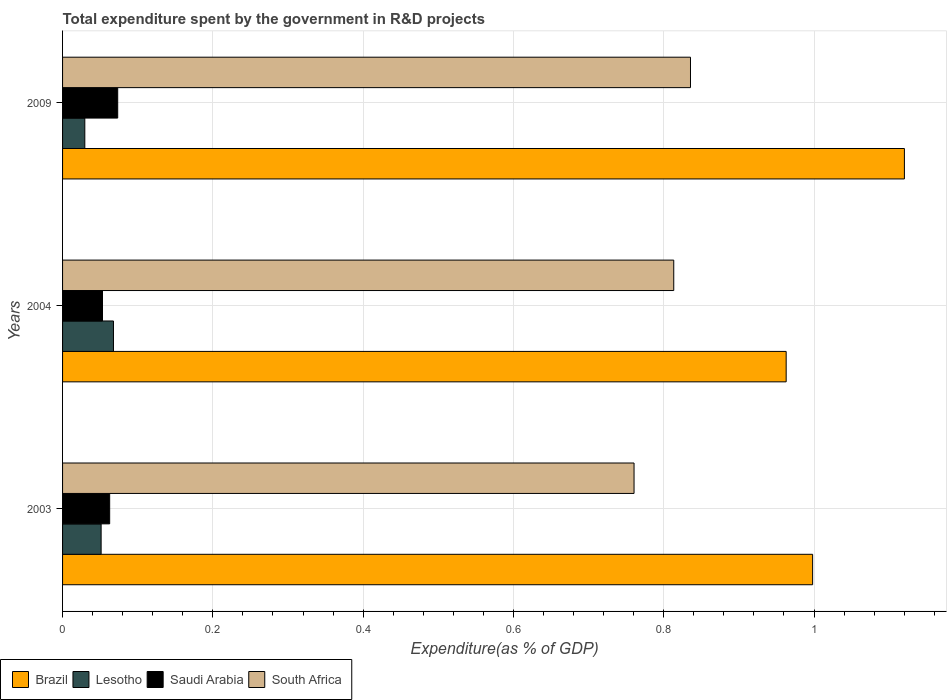Are the number of bars per tick equal to the number of legend labels?
Give a very brief answer. Yes. Are the number of bars on each tick of the Y-axis equal?
Provide a succinct answer. Yes. How many bars are there on the 3rd tick from the top?
Ensure brevity in your answer.  4. How many bars are there on the 1st tick from the bottom?
Make the answer very short. 4. In how many cases, is the number of bars for a given year not equal to the number of legend labels?
Your response must be concise. 0. What is the total expenditure spent by the government in R&D projects in Lesotho in 2003?
Your answer should be very brief. 0.05. Across all years, what is the maximum total expenditure spent by the government in R&D projects in South Africa?
Your response must be concise. 0.84. Across all years, what is the minimum total expenditure spent by the government in R&D projects in Lesotho?
Offer a terse response. 0.03. In which year was the total expenditure spent by the government in R&D projects in Brazil maximum?
Offer a terse response. 2009. What is the total total expenditure spent by the government in R&D projects in Saudi Arabia in the graph?
Keep it short and to the point. 0.19. What is the difference between the total expenditure spent by the government in R&D projects in South Africa in 2003 and that in 2004?
Ensure brevity in your answer.  -0.05. What is the difference between the total expenditure spent by the government in R&D projects in Saudi Arabia in 2009 and the total expenditure spent by the government in R&D projects in Lesotho in 2003?
Your response must be concise. 0.02. What is the average total expenditure spent by the government in R&D projects in South Africa per year?
Ensure brevity in your answer.  0.8. In the year 2009, what is the difference between the total expenditure spent by the government in R&D projects in Saudi Arabia and total expenditure spent by the government in R&D projects in South Africa?
Offer a terse response. -0.76. What is the ratio of the total expenditure spent by the government in R&D projects in Lesotho in 2004 to that in 2009?
Ensure brevity in your answer.  2.29. Is the total expenditure spent by the government in R&D projects in Lesotho in 2004 less than that in 2009?
Offer a terse response. No. Is the difference between the total expenditure spent by the government in R&D projects in Saudi Arabia in 2004 and 2009 greater than the difference between the total expenditure spent by the government in R&D projects in South Africa in 2004 and 2009?
Keep it short and to the point. Yes. What is the difference between the highest and the second highest total expenditure spent by the government in R&D projects in South Africa?
Make the answer very short. 0.02. What is the difference between the highest and the lowest total expenditure spent by the government in R&D projects in South Africa?
Make the answer very short. 0.08. Is the sum of the total expenditure spent by the government in R&D projects in Brazil in 2004 and 2009 greater than the maximum total expenditure spent by the government in R&D projects in Lesotho across all years?
Ensure brevity in your answer.  Yes. What does the 1st bar from the top in 2004 represents?
Give a very brief answer. South Africa. What does the 2nd bar from the bottom in 2003 represents?
Provide a succinct answer. Lesotho. How many bars are there?
Offer a very short reply. 12. Are all the bars in the graph horizontal?
Your answer should be very brief. Yes. Does the graph contain any zero values?
Your answer should be very brief. No. Does the graph contain grids?
Offer a very short reply. Yes. How many legend labels are there?
Offer a very short reply. 4. What is the title of the graph?
Keep it short and to the point. Total expenditure spent by the government in R&D projects. What is the label or title of the X-axis?
Give a very brief answer. Expenditure(as % of GDP). What is the Expenditure(as % of GDP) in Brazil in 2003?
Keep it short and to the point. 1. What is the Expenditure(as % of GDP) of Lesotho in 2003?
Make the answer very short. 0.05. What is the Expenditure(as % of GDP) of Saudi Arabia in 2003?
Your answer should be very brief. 0.06. What is the Expenditure(as % of GDP) in South Africa in 2003?
Ensure brevity in your answer.  0.76. What is the Expenditure(as % of GDP) in Brazil in 2004?
Your response must be concise. 0.96. What is the Expenditure(as % of GDP) in Lesotho in 2004?
Provide a short and direct response. 0.07. What is the Expenditure(as % of GDP) of Saudi Arabia in 2004?
Ensure brevity in your answer.  0.05. What is the Expenditure(as % of GDP) of South Africa in 2004?
Provide a short and direct response. 0.81. What is the Expenditure(as % of GDP) in Brazil in 2009?
Provide a short and direct response. 1.12. What is the Expenditure(as % of GDP) in Lesotho in 2009?
Your response must be concise. 0.03. What is the Expenditure(as % of GDP) in Saudi Arabia in 2009?
Offer a very short reply. 0.07. What is the Expenditure(as % of GDP) of South Africa in 2009?
Provide a short and direct response. 0.84. Across all years, what is the maximum Expenditure(as % of GDP) of Brazil?
Make the answer very short. 1.12. Across all years, what is the maximum Expenditure(as % of GDP) in Lesotho?
Your answer should be compact. 0.07. Across all years, what is the maximum Expenditure(as % of GDP) in Saudi Arabia?
Provide a short and direct response. 0.07. Across all years, what is the maximum Expenditure(as % of GDP) of South Africa?
Provide a succinct answer. 0.84. Across all years, what is the minimum Expenditure(as % of GDP) in Brazil?
Make the answer very short. 0.96. Across all years, what is the minimum Expenditure(as % of GDP) in Lesotho?
Make the answer very short. 0.03. Across all years, what is the minimum Expenditure(as % of GDP) in Saudi Arabia?
Offer a terse response. 0.05. Across all years, what is the minimum Expenditure(as % of GDP) of South Africa?
Give a very brief answer. 0.76. What is the total Expenditure(as % of GDP) in Brazil in the graph?
Keep it short and to the point. 3.08. What is the total Expenditure(as % of GDP) of Lesotho in the graph?
Provide a short and direct response. 0.15. What is the total Expenditure(as % of GDP) of Saudi Arabia in the graph?
Your response must be concise. 0.19. What is the total Expenditure(as % of GDP) of South Africa in the graph?
Your answer should be compact. 2.41. What is the difference between the Expenditure(as % of GDP) in Brazil in 2003 and that in 2004?
Make the answer very short. 0.04. What is the difference between the Expenditure(as % of GDP) in Lesotho in 2003 and that in 2004?
Provide a succinct answer. -0.02. What is the difference between the Expenditure(as % of GDP) in Saudi Arabia in 2003 and that in 2004?
Offer a terse response. 0.01. What is the difference between the Expenditure(as % of GDP) of South Africa in 2003 and that in 2004?
Offer a terse response. -0.05. What is the difference between the Expenditure(as % of GDP) in Brazil in 2003 and that in 2009?
Give a very brief answer. -0.12. What is the difference between the Expenditure(as % of GDP) in Lesotho in 2003 and that in 2009?
Offer a very short reply. 0.02. What is the difference between the Expenditure(as % of GDP) of Saudi Arabia in 2003 and that in 2009?
Provide a short and direct response. -0.01. What is the difference between the Expenditure(as % of GDP) of South Africa in 2003 and that in 2009?
Ensure brevity in your answer.  -0.08. What is the difference between the Expenditure(as % of GDP) in Brazil in 2004 and that in 2009?
Provide a succinct answer. -0.16. What is the difference between the Expenditure(as % of GDP) of Lesotho in 2004 and that in 2009?
Keep it short and to the point. 0.04. What is the difference between the Expenditure(as % of GDP) of Saudi Arabia in 2004 and that in 2009?
Provide a succinct answer. -0.02. What is the difference between the Expenditure(as % of GDP) in South Africa in 2004 and that in 2009?
Offer a very short reply. -0.02. What is the difference between the Expenditure(as % of GDP) in Brazil in 2003 and the Expenditure(as % of GDP) in Lesotho in 2004?
Provide a short and direct response. 0.93. What is the difference between the Expenditure(as % of GDP) of Brazil in 2003 and the Expenditure(as % of GDP) of Saudi Arabia in 2004?
Offer a terse response. 0.94. What is the difference between the Expenditure(as % of GDP) in Brazil in 2003 and the Expenditure(as % of GDP) in South Africa in 2004?
Your answer should be very brief. 0.18. What is the difference between the Expenditure(as % of GDP) of Lesotho in 2003 and the Expenditure(as % of GDP) of Saudi Arabia in 2004?
Offer a very short reply. -0. What is the difference between the Expenditure(as % of GDP) in Lesotho in 2003 and the Expenditure(as % of GDP) in South Africa in 2004?
Offer a terse response. -0.76. What is the difference between the Expenditure(as % of GDP) in Saudi Arabia in 2003 and the Expenditure(as % of GDP) in South Africa in 2004?
Your answer should be compact. -0.75. What is the difference between the Expenditure(as % of GDP) of Brazil in 2003 and the Expenditure(as % of GDP) of Lesotho in 2009?
Offer a terse response. 0.97. What is the difference between the Expenditure(as % of GDP) of Brazil in 2003 and the Expenditure(as % of GDP) of Saudi Arabia in 2009?
Offer a very short reply. 0.92. What is the difference between the Expenditure(as % of GDP) of Brazil in 2003 and the Expenditure(as % of GDP) of South Africa in 2009?
Offer a very short reply. 0.16. What is the difference between the Expenditure(as % of GDP) in Lesotho in 2003 and the Expenditure(as % of GDP) in Saudi Arabia in 2009?
Provide a succinct answer. -0.02. What is the difference between the Expenditure(as % of GDP) of Lesotho in 2003 and the Expenditure(as % of GDP) of South Africa in 2009?
Ensure brevity in your answer.  -0.78. What is the difference between the Expenditure(as % of GDP) of Saudi Arabia in 2003 and the Expenditure(as % of GDP) of South Africa in 2009?
Provide a succinct answer. -0.77. What is the difference between the Expenditure(as % of GDP) of Brazil in 2004 and the Expenditure(as % of GDP) of Lesotho in 2009?
Offer a terse response. 0.93. What is the difference between the Expenditure(as % of GDP) in Brazil in 2004 and the Expenditure(as % of GDP) in Saudi Arabia in 2009?
Keep it short and to the point. 0.89. What is the difference between the Expenditure(as % of GDP) of Brazil in 2004 and the Expenditure(as % of GDP) of South Africa in 2009?
Keep it short and to the point. 0.13. What is the difference between the Expenditure(as % of GDP) of Lesotho in 2004 and the Expenditure(as % of GDP) of Saudi Arabia in 2009?
Provide a succinct answer. -0.01. What is the difference between the Expenditure(as % of GDP) of Lesotho in 2004 and the Expenditure(as % of GDP) of South Africa in 2009?
Your response must be concise. -0.77. What is the difference between the Expenditure(as % of GDP) of Saudi Arabia in 2004 and the Expenditure(as % of GDP) of South Africa in 2009?
Your response must be concise. -0.78. What is the average Expenditure(as % of GDP) in Brazil per year?
Offer a very short reply. 1.03. What is the average Expenditure(as % of GDP) of Lesotho per year?
Your answer should be compact. 0.05. What is the average Expenditure(as % of GDP) in Saudi Arabia per year?
Keep it short and to the point. 0.06. What is the average Expenditure(as % of GDP) in South Africa per year?
Your response must be concise. 0.8. In the year 2003, what is the difference between the Expenditure(as % of GDP) of Brazil and Expenditure(as % of GDP) of Lesotho?
Provide a short and direct response. 0.95. In the year 2003, what is the difference between the Expenditure(as % of GDP) in Brazil and Expenditure(as % of GDP) in Saudi Arabia?
Your answer should be compact. 0.94. In the year 2003, what is the difference between the Expenditure(as % of GDP) in Brazil and Expenditure(as % of GDP) in South Africa?
Offer a very short reply. 0.24. In the year 2003, what is the difference between the Expenditure(as % of GDP) in Lesotho and Expenditure(as % of GDP) in Saudi Arabia?
Provide a succinct answer. -0.01. In the year 2003, what is the difference between the Expenditure(as % of GDP) in Lesotho and Expenditure(as % of GDP) in South Africa?
Provide a succinct answer. -0.71. In the year 2003, what is the difference between the Expenditure(as % of GDP) of Saudi Arabia and Expenditure(as % of GDP) of South Africa?
Offer a terse response. -0.7. In the year 2004, what is the difference between the Expenditure(as % of GDP) of Brazil and Expenditure(as % of GDP) of Lesotho?
Offer a terse response. 0.9. In the year 2004, what is the difference between the Expenditure(as % of GDP) of Brazil and Expenditure(as % of GDP) of Saudi Arabia?
Your response must be concise. 0.91. In the year 2004, what is the difference between the Expenditure(as % of GDP) of Brazil and Expenditure(as % of GDP) of South Africa?
Make the answer very short. 0.15. In the year 2004, what is the difference between the Expenditure(as % of GDP) of Lesotho and Expenditure(as % of GDP) of Saudi Arabia?
Keep it short and to the point. 0.01. In the year 2004, what is the difference between the Expenditure(as % of GDP) in Lesotho and Expenditure(as % of GDP) in South Africa?
Keep it short and to the point. -0.75. In the year 2004, what is the difference between the Expenditure(as % of GDP) of Saudi Arabia and Expenditure(as % of GDP) of South Africa?
Your response must be concise. -0.76. In the year 2009, what is the difference between the Expenditure(as % of GDP) in Brazil and Expenditure(as % of GDP) in Lesotho?
Ensure brevity in your answer.  1.09. In the year 2009, what is the difference between the Expenditure(as % of GDP) in Brazil and Expenditure(as % of GDP) in Saudi Arabia?
Your answer should be very brief. 1.05. In the year 2009, what is the difference between the Expenditure(as % of GDP) in Brazil and Expenditure(as % of GDP) in South Africa?
Provide a short and direct response. 0.28. In the year 2009, what is the difference between the Expenditure(as % of GDP) of Lesotho and Expenditure(as % of GDP) of Saudi Arabia?
Your answer should be very brief. -0.04. In the year 2009, what is the difference between the Expenditure(as % of GDP) in Lesotho and Expenditure(as % of GDP) in South Africa?
Give a very brief answer. -0.81. In the year 2009, what is the difference between the Expenditure(as % of GDP) in Saudi Arabia and Expenditure(as % of GDP) in South Africa?
Your response must be concise. -0.76. What is the ratio of the Expenditure(as % of GDP) of Brazil in 2003 to that in 2004?
Your answer should be compact. 1.04. What is the ratio of the Expenditure(as % of GDP) of Lesotho in 2003 to that in 2004?
Give a very brief answer. 0.76. What is the ratio of the Expenditure(as % of GDP) of Saudi Arabia in 2003 to that in 2004?
Your answer should be compact. 1.18. What is the ratio of the Expenditure(as % of GDP) in South Africa in 2003 to that in 2004?
Your answer should be compact. 0.94. What is the ratio of the Expenditure(as % of GDP) in Brazil in 2003 to that in 2009?
Give a very brief answer. 0.89. What is the ratio of the Expenditure(as % of GDP) of Lesotho in 2003 to that in 2009?
Give a very brief answer. 1.73. What is the ratio of the Expenditure(as % of GDP) in Saudi Arabia in 2003 to that in 2009?
Your answer should be very brief. 0.85. What is the ratio of the Expenditure(as % of GDP) of South Africa in 2003 to that in 2009?
Give a very brief answer. 0.91. What is the ratio of the Expenditure(as % of GDP) in Brazil in 2004 to that in 2009?
Offer a very short reply. 0.86. What is the ratio of the Expenditure(as % of GDP) in Lesotho in 2004 to that in 2009?
Offer a terse response. 2.29. What is the ratio of the Expenditure(as % of GDP) in Saudi Arabia in 2004 to that in 2009?
Make the answer very short. 0.72. What is the ratio of the Expenditure(as % of GDP) of South Africa in 2004 to that in 2009?
Make the answer very short. 0.97. What is the difference between the highest and the second highest Expenditure(as % of GDP) of Brazil?
Your response must be concise. 0.12. What is the difference between the highest and the second highest Expenditure(as % of GDP) in Lesotho?
Ensure brevity in your answer.  0.02. What is the difference between the highest and the second highest Expenditure(as % of GDP) of Saudi Arabia?
Offer a very short reply. 0.01. What is the difference between the highest and the second highest Expenditure(as % of GDP) of South Africa?
Provide a succinct answer. 0.02. What is the difference between the highest and the lowest Expenditure(as % of GDP) in Brazil?
Provide a succinct answer. 0.16. What is the difference between the highest and the lowest Expenditure(as % of GDP) in Lesotho?
Provide a succinct answer. 0.04. What is the difference between the highest and the lowest Expenditure(as % of GDP) of Saudi Arabia?
Ensure brevity in your answer.  0.02. What is the difference between the highest and the lowest Expenditure(as % of GDP) in South Africa?
Make the answer very short. 0.08. 